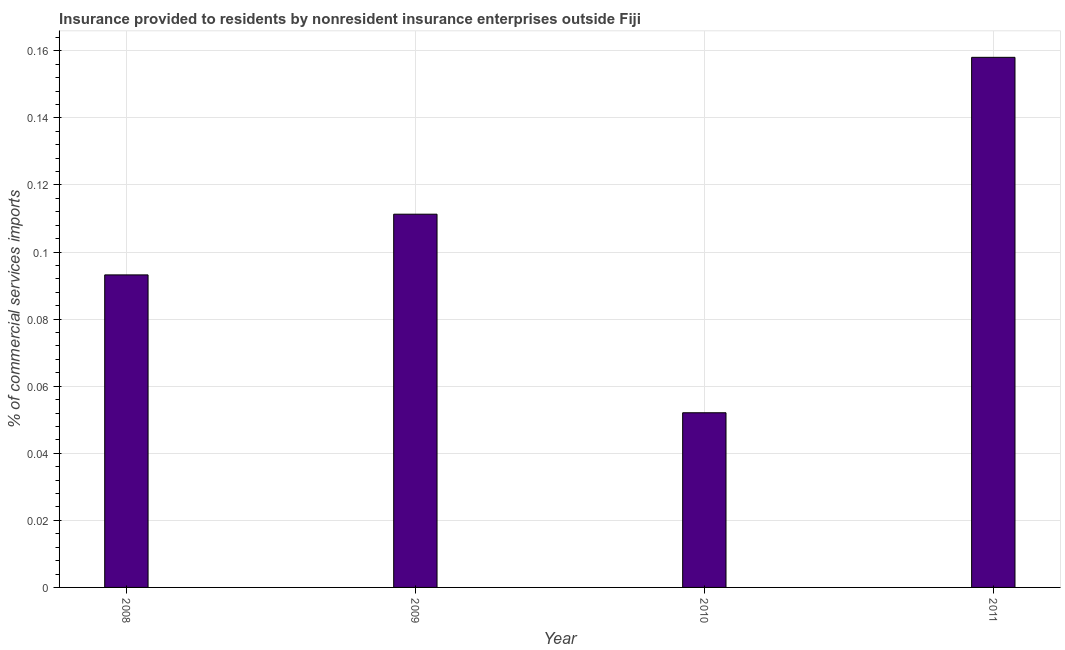Does the graph contain any zero values?
Provide a succinct answer. No. What is the title of the graph?
Offer a very short reply. Insurance provided to residents by nonresident insurance enterprises outside Fiji. What is the label or title of the X-axis?
Your answer should be compact. Year. What is the label or title of the Y-axis?
Ensure brevity in your answer.  % of commercial services imports. What is the insurance provided by non-residents in 2008?
Make the answer very short. 0.09. Across all years, what is the maximum insurance provided by non-residents?
Make the answer very short. 0.16. Across all years, what is the minimum insurance provided by non-residents?
Offer a very short reply. 0.05. In which year was the insurance provided by non-residents maximum?
Keep it short and to the point. 2011. What is the sum of the insurance provided by non-residents?
Offer a terse response. 0.41. What is the difference between the insurance provided by non-residents in 2008 and 2010?
Offer a terse response. 0.04. What is the average insurance provided by non-residents per year?
Make the answer very short. 0.1. What is the median insurance provided by non-residents?
Provide a succinct answer. 0.1. Do a majority of the years between 2009 and 2011 (inclusive) have insurance provided by non-residents greater than 0.124 %?
Your answer should be compact. No. What is the ratio of the insurance provided by non-residents in 2010 to that in 2011?
Provide a short and direct response. 0.33. Is the difference between the insurance provided by non-residents in 2009 and 2011 greater than the difference between any two years?
Provide a succinct answer. No. What is the difference between the highest and the second highest insurance provided by non-residents?
Offer a very short reply. 0.05. Is the sum of the insurance provided by non-residents in 2008 and 2011 greater than the maximum insurance provided by non-residents across all years?
Provide a succinct answer. Yes. What is the difference between the highest and the lowest insurance provided by non-residents?
Your answer should be compact. 0.11. Are all the bars in the graph horizontal?
Your answer should be very brief. No. What is the difference between two consecutive major ticks on the Y-axis?
Your response must be concise. 0.02. Are the values on the major ticks of Y-axis written in scientific E-notation?
Offer a very short reply. No. What is the % of commercial services imports in 2008?
Provide a short and direct response. 0.09. What is the % of commercial services imports in 2009?
Offer a terse response. 0.11. What is the % of commercial services imports of 2010?
Your response must be concise. 0.05. What is the % of commercial services imports in 2011?
Your answer should be compact. 0.16. What is the difference between the % of commercial services imports in 2008 and 2009?
Your answer should be very brief. -0.02. What is the difference between the % of commercial services imports in 2008 and 2010?
Make the answer very short. 0.04. What is the difference between the % of commercial services imports in 2008 and 2011?
Keep it short and to the point. -0.06. What is the difference between the % of commercial services imports in 2009 and 2010?
Provide a short and direct response. 0.06. What is the difference between the % of commercial services imports in 2009 and 2011?
Give a very brief answer. -0.05. What is the difference between the % of commercial services imports in 2010 and 2011?
Your response must be concise. -0.11. What is the ratio of the % of commercial services imports in 2008 to that in 2009?
Offer a terse response. 0.84. What is the ratio of the % of commercial services imports in 2008 to that in 2010?
Your response must be concise. 1.79. What is the ratio of the % of commercial services imports in 2008 to that in 2011?
Provide a succinct answer. 0.59. What is the ratio of the % of commercial services imports in 2009 to that in 2010?
Ensure brevity in your answer.  2.14. What is the ratio of the % of commercial services imports in 2009 to that in 2011?
Provide a succinct answer. 0.7. What is the ratio of the % of commercial services imports in 2010 to that in 2011?
Provide a succinct answer. 0.33. 